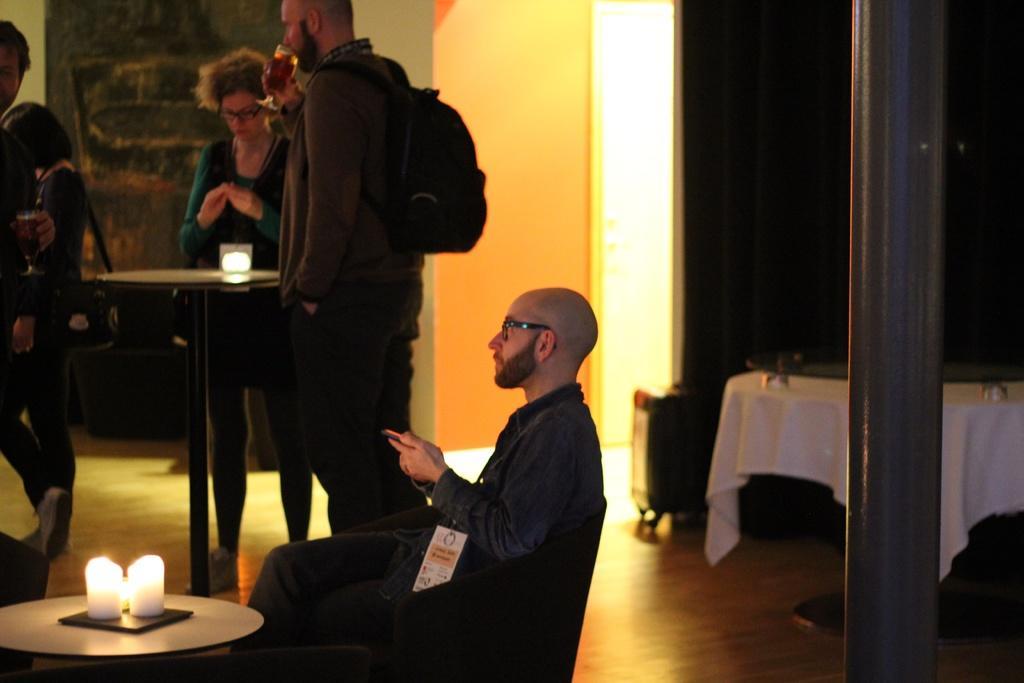Describe this image in one or two sentences. Person sitting on the chair on table we have candle and a woman standing and a person holding a glass. 